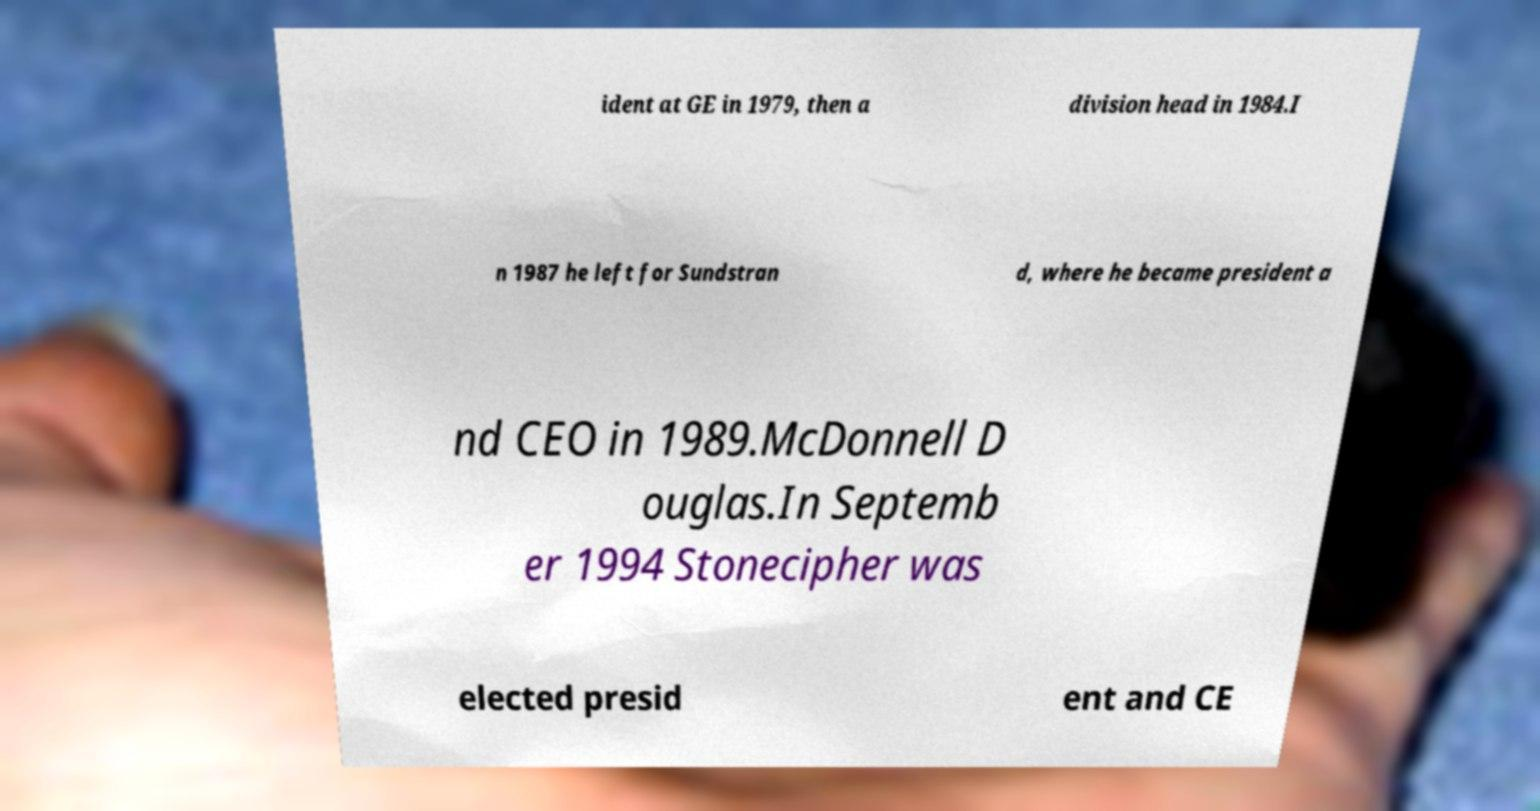What messages or text are displayed in this image? I need them in a readable, typed format. ident at GE in 1979, then a division head in 1984.I n 1987 he left for Sundstran d, where he became president a nd CEO in 1989.McDonnell D ouglas.In Septemb er 1994 Stonecipher was elected presid ent and CE 